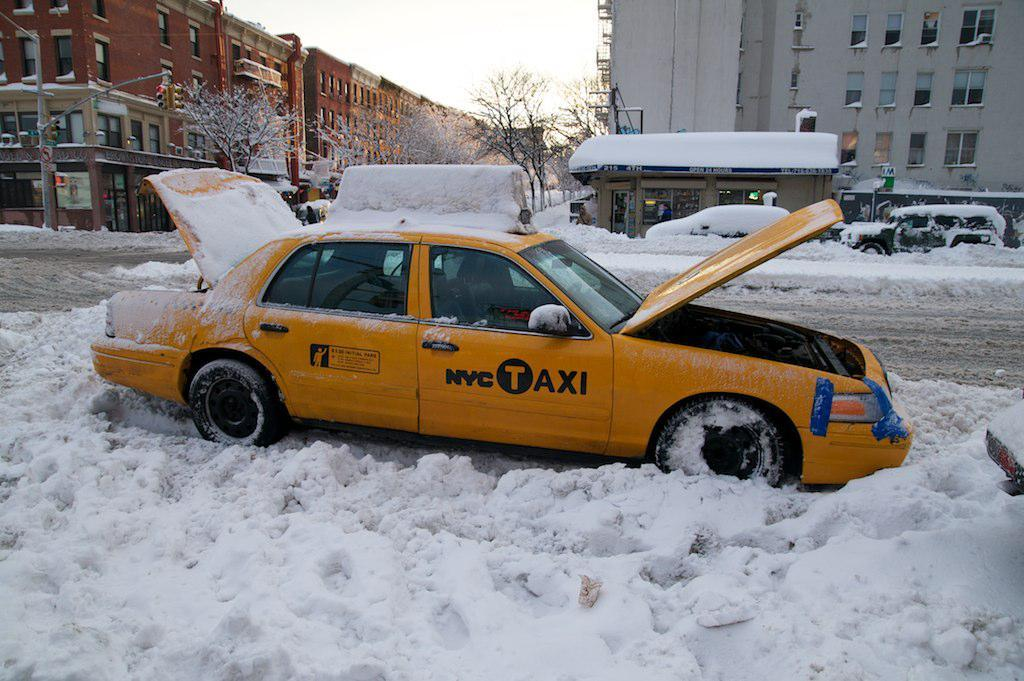<image>
Provide a brief description of the given image. A NYC Taxi is stuck in the snow awaiting help. 